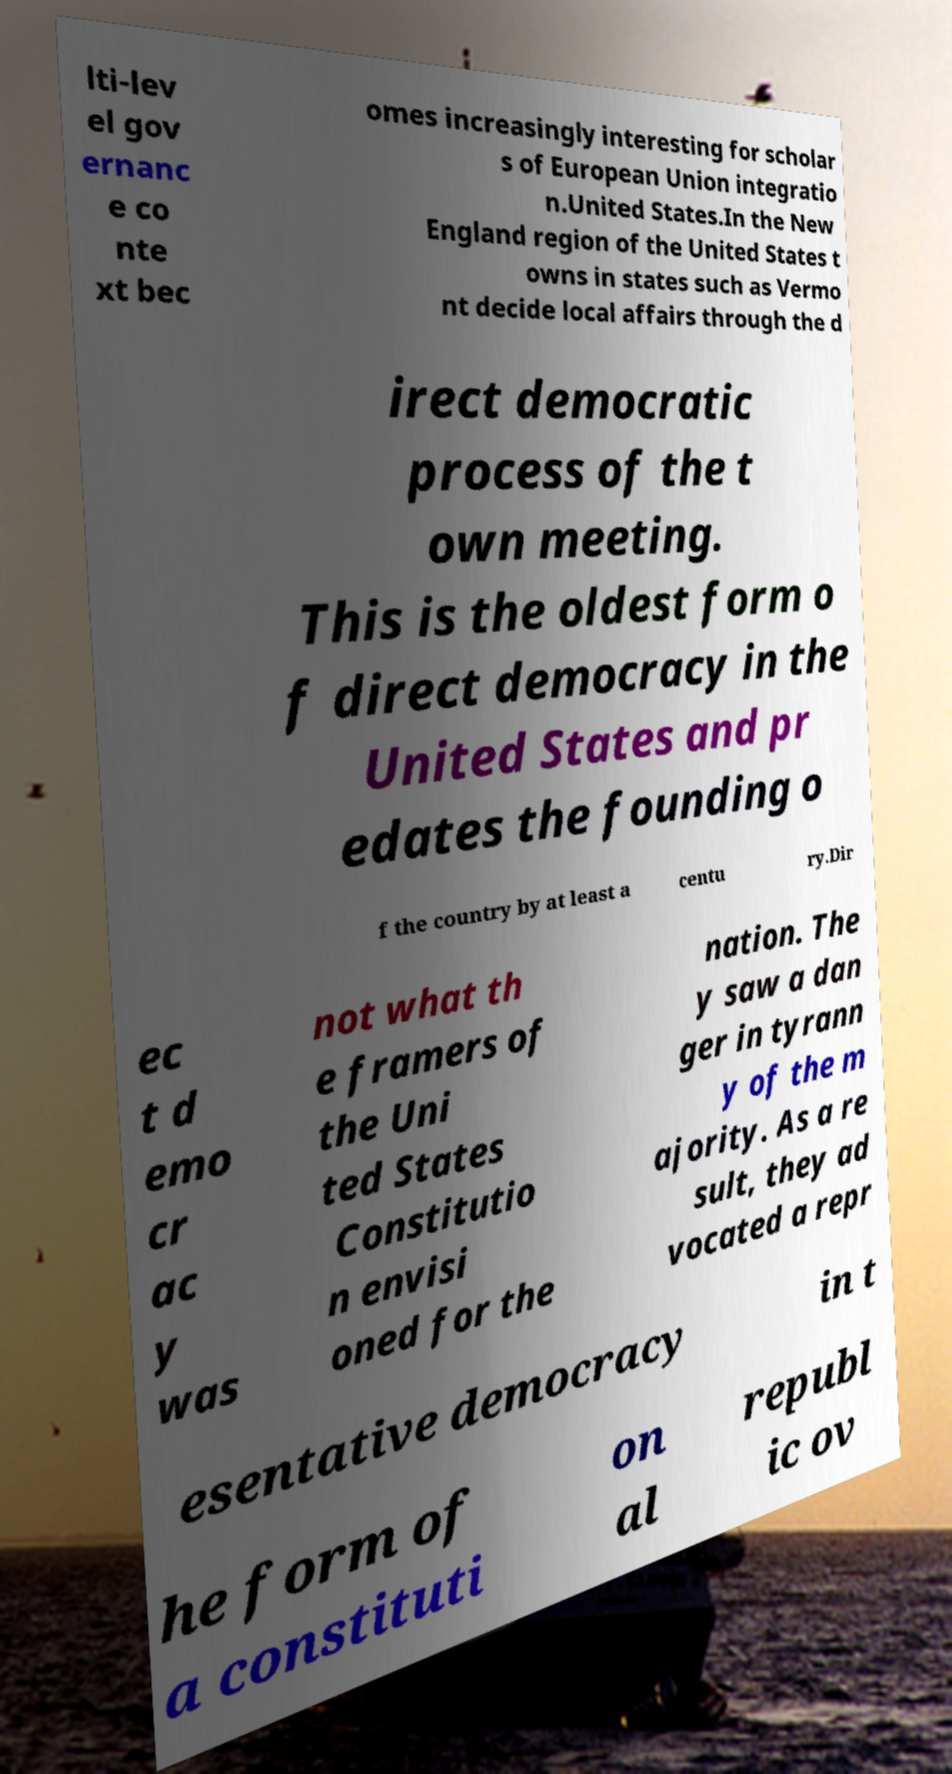For documentation purposes, I need the text within this image transcribed. Could you provide that? lti-lev el gov ernanc e co nte xt bec omes increasingly interesting for scholar s of European Union integratio n.United States.In the New England region of the United States t owns in states such as Vermo nt decide local affairs through the d irect democratic process of the t own meeting. This is the oldest form o f direct democracy in the United States and pr edates the founding o f the country by at least a centu ry.Dir ec t d emo cr ac y was not what th e framers of the Uni ted States Constitutio n envisi oned for the nation. The y saw a dan ger in tyrann y of the m ajority. As a re sult, they ad vocated a repr esentative democracy in t he form of a constituti on al republ ic ov 